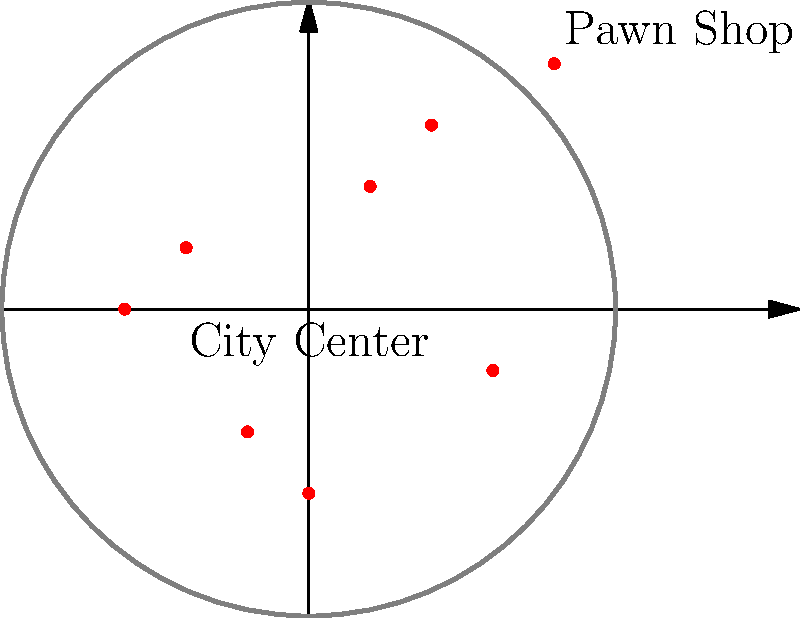Based on the distribution of pawn shops shown on the map, which area of the city appears to have the highest concentration of pawn shops, and what implications might this have for vulnerable individuals seeking loans in that area? To answer this question, we need to analyze the distribution of pawn shops on the map and consider the implications for vulnerable individuals. Let's break it down step-by-step:

1. Observe the distribution: The map shows 7 pawn shops represented by red dots within a circular city boundary.

2. Identify concentrations: 
   - There are 3 pawn shops in the upper-right quadrant (northeast).
   - 2 pawn shops are located in the lower-left quadrant (southwest).
   - The remaining 2 are spread between the other quadrants.

3. Highest concentration: The northeast quadrant has the highest concentration with 3 pawn shops.

4. Implications for vulnerable individuals:
   a) Increased access: More pawn shops in an area may provide easier access to quick loans for those in need.
   b) Competition: Higher concentration might lead to more competitive rates or terms, potentially benefiting borrowers.
   c) Predatory practices: Conversely, a high concentration could indicate an area of economic distress, where vulnerable individuals might be more easily exploited.
   d) Community impact: The prevalence of pawn shops might affect the overall economic health and perception of the neighborhood.
   e) Need for services: This concentration might indicate a higher demand for financial assistance and social services in the area.

5. Social work perspective: As a social worker, it's important to recognize that while pawn shops can provide short-term financial relief, they may also contribute to cycles of debt. The high concentration in the northeast quadrant suggests a need for targeted financial education, alternative lending options, and support services in this area.
Answer: Northeast quadrant; increased access but potential for exploitation, indicating a need for targeted financial education and support services. 